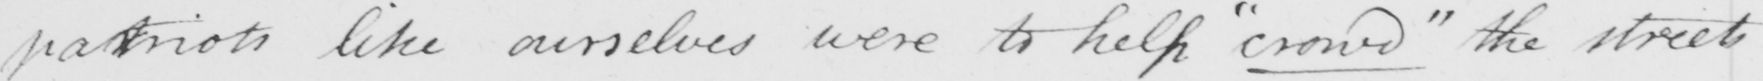What is written in this line of handwriting? patriots like ourselves were to help  " crowd "  the streets 